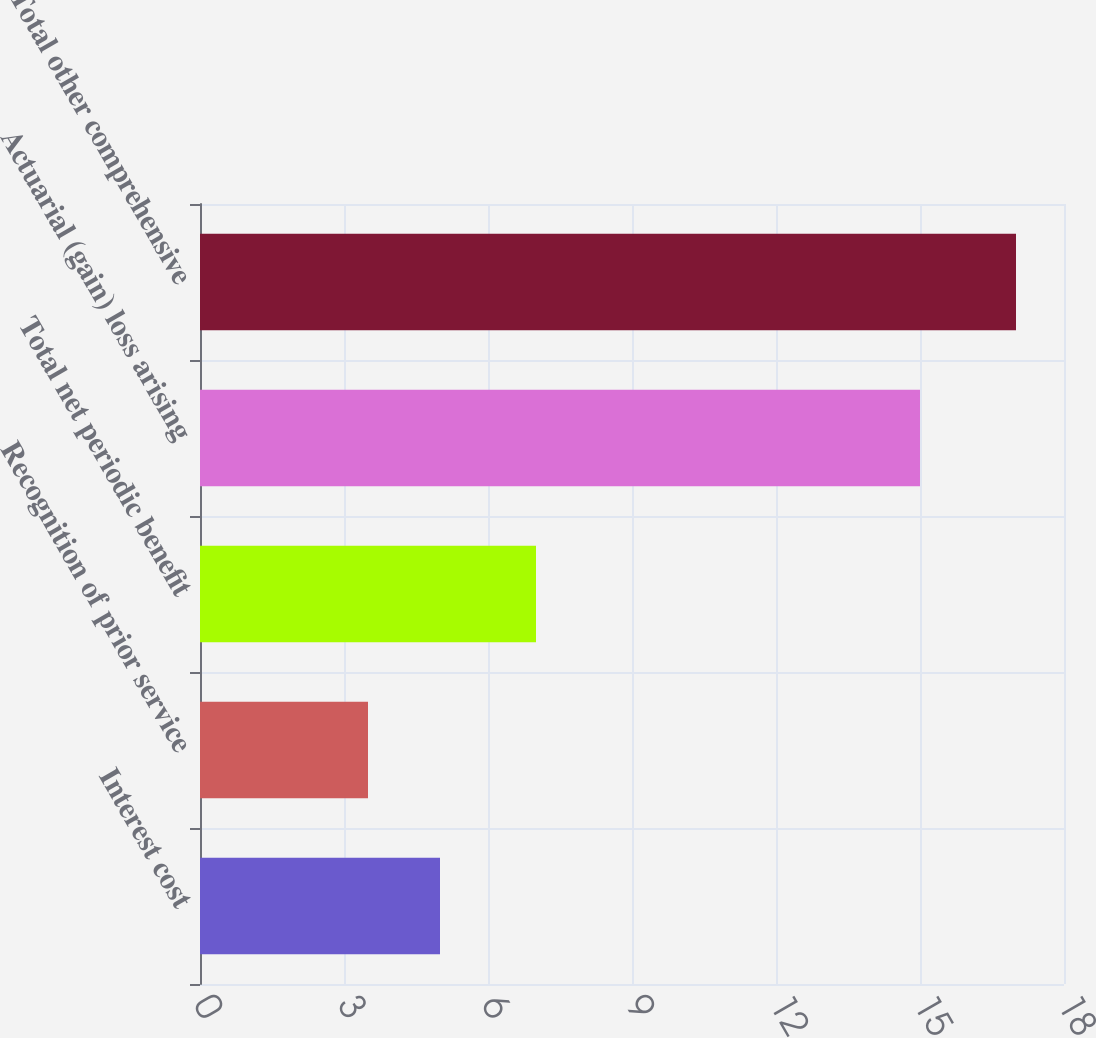<chart> <loc_0><loc_0><loc_500><loc_500><bar_chart><fcel>Interest cost<fcel>Recognition of prior service<fcel>Total net periodic benefit<fcel>Actuarial (gain) loss arising<fcel>Total other comprehensive<nl><fcel>5<fcel>3.5<fcel>7<fcel>15<fcel>17<nl></chart> 